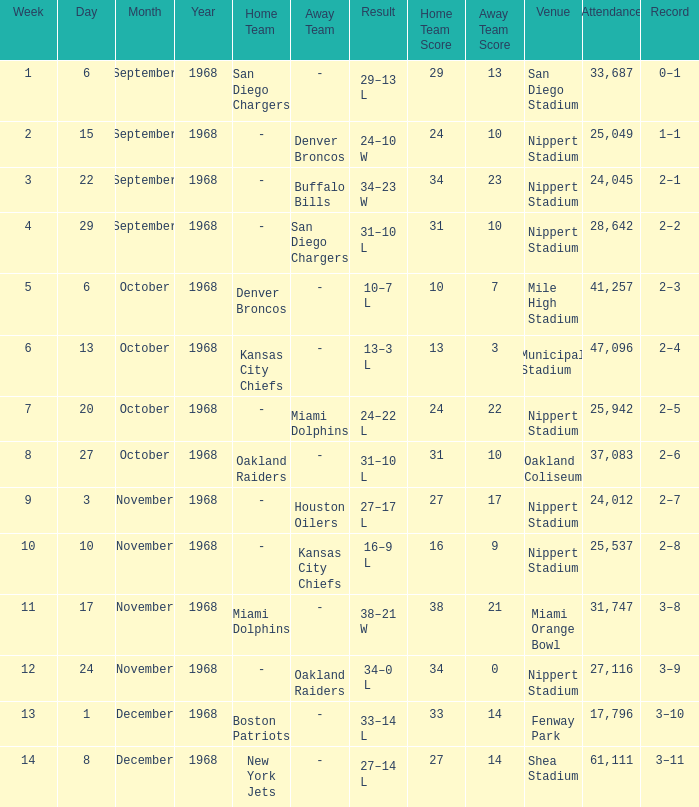What date was the week 6 game played on? October 13, 1968. 